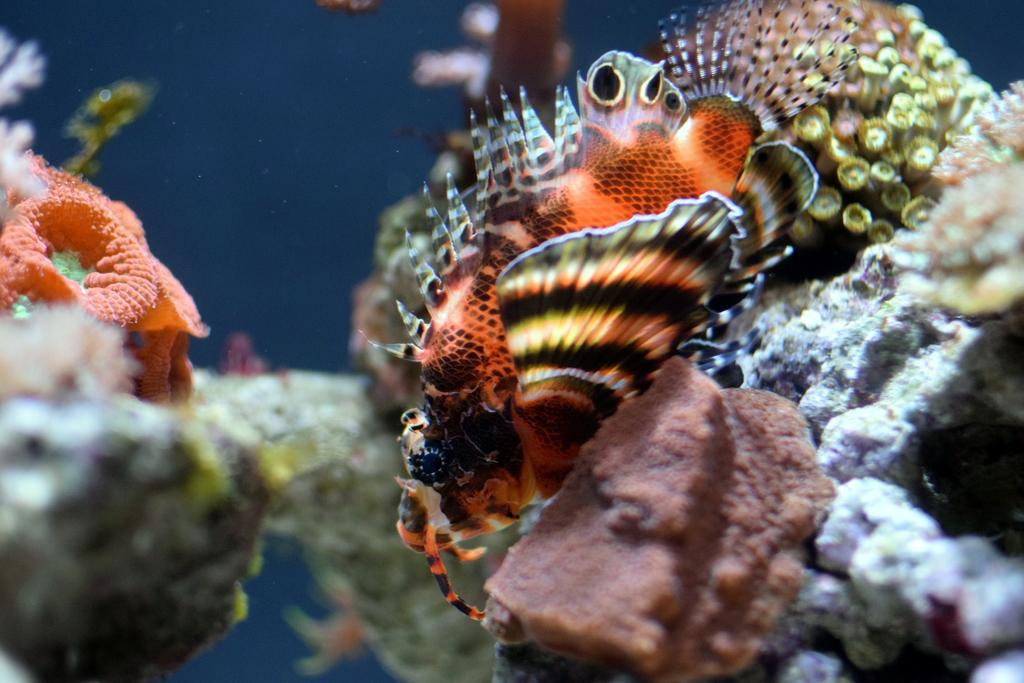Where is the picture taken? The picture is taken inside the water. What is the main subject in the center of the image? There is a fish in the center of the image. What can be seen around the fish? There are coral reefs around the fish. What type of lace can be seen on the fish's fin in the image? There is no lace present on the fish's fin in the image. In which direction is the fish swimming in the image? The image does not show the fish swimming, so it cannot be determined which direction it is facing. 